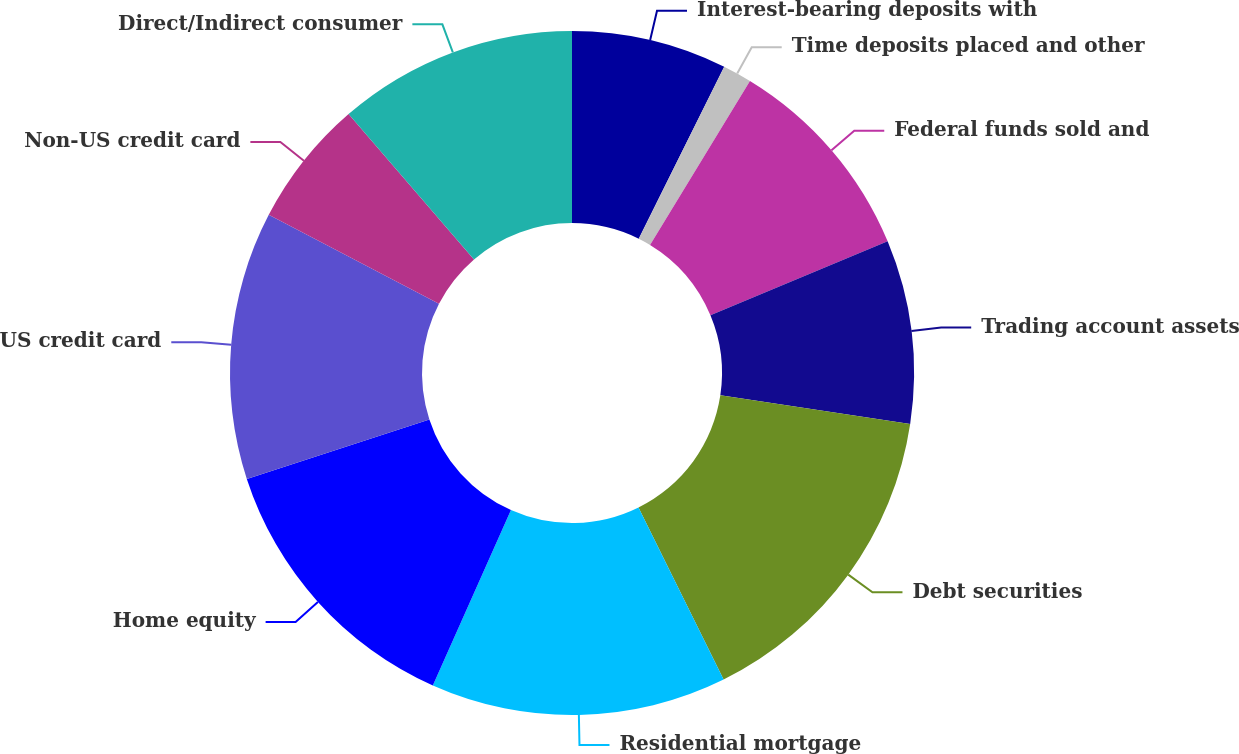Convert chart. <chart><loc_0><loc_0><loc_500><loc_500><pie_chart><fcel>Interest-bearing deposits with<fcel>Time deposits placed and other<fcel>Federal funds sold and<fcel>Trading account assets<fcel>Debt securities<fcel>Residential mortgage<fcel>Home equity<fcel>US credit card<fcel>Non-US credit card<fcel>Direct/Indirect consumer<nl><fcel>7.34%<fcel>1.37%<fcel>10.0%<fcel>8.67%<fcel>15.31%<fcel>13.98%<fcel>13.32%<fcel>12.66%<fcel>6.02%<fcel>11.33%<nl></chart> 